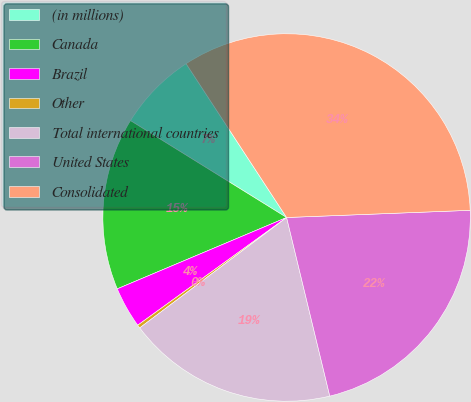Convert chart. <chart><loc_0><loc_0><loc_500><loc_500><pie_chart><fcel>(in millions)<fcel>Canada<fcel>Brazil<fcel>Other<fcel>Total international countries<fcel>United States<fcel>Consolidated<nl><fcel>6.95%<fcel>15.19%<fcel>3.62%<fcel>0.29%<fcel>18.52%<fcel>21.85%<fcel>33.59%<nl></chart> 